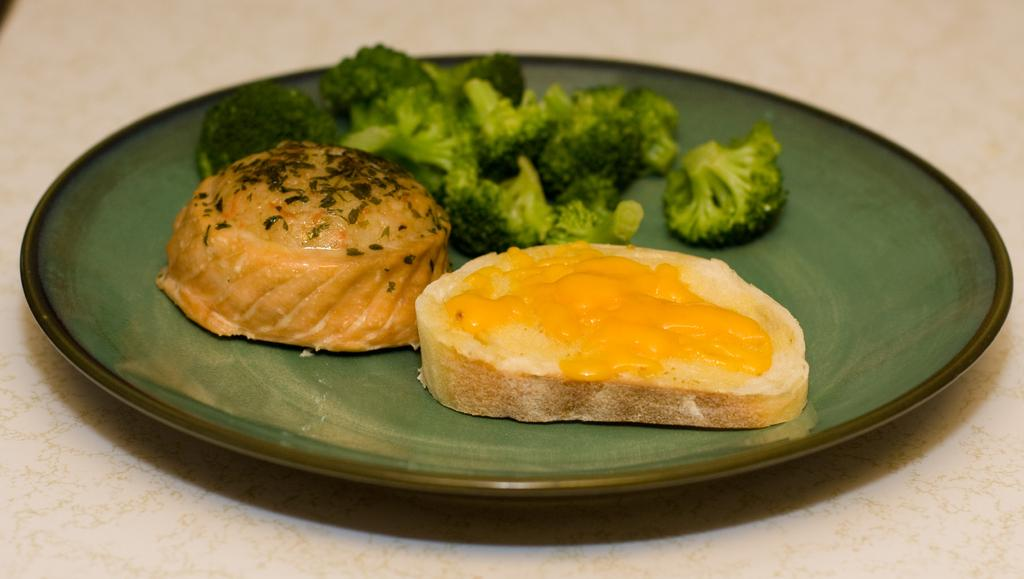What color is the plate that is visible in the image? There is a green plate in the image. What type of vegetable is on the plate? There is broccoli on the plate. Are there any other food items on the plate besides broccoli? Yes, there are other food items on the plate. What does the pet do to help with cooking the food on the plate? There is no pet present in the image, so it cannot help with cooking the food on the plate. 